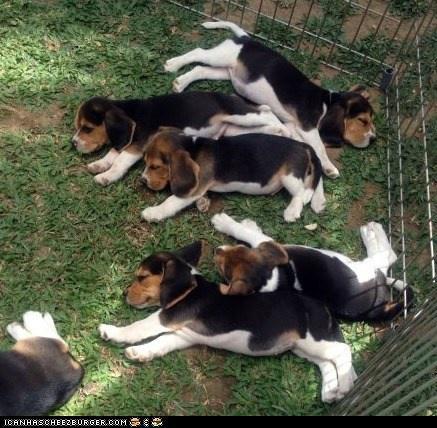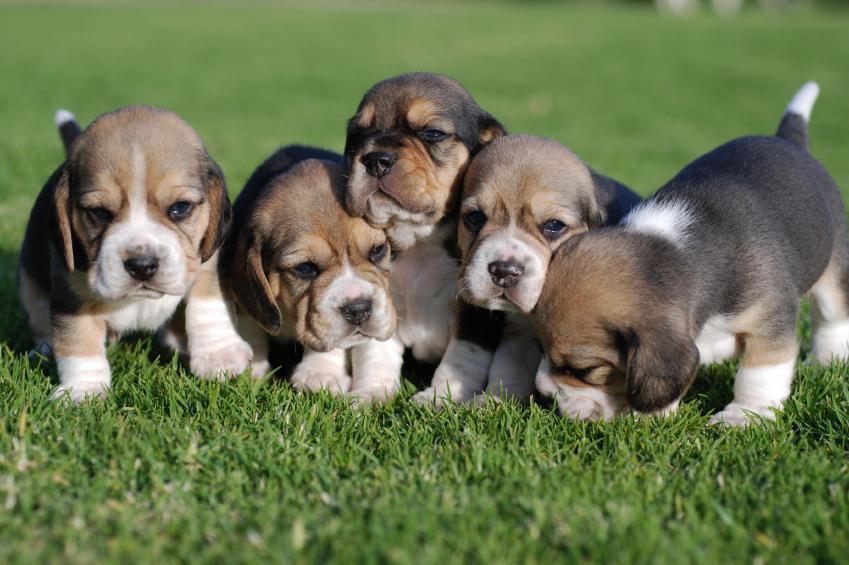The first image is the image on the left, the second image is the image on the right. Evaluate the accuracy of this statement regarding the images: "A bloody carcass lies in the grass in one image.". Is it true? Answer yes or no. No. 